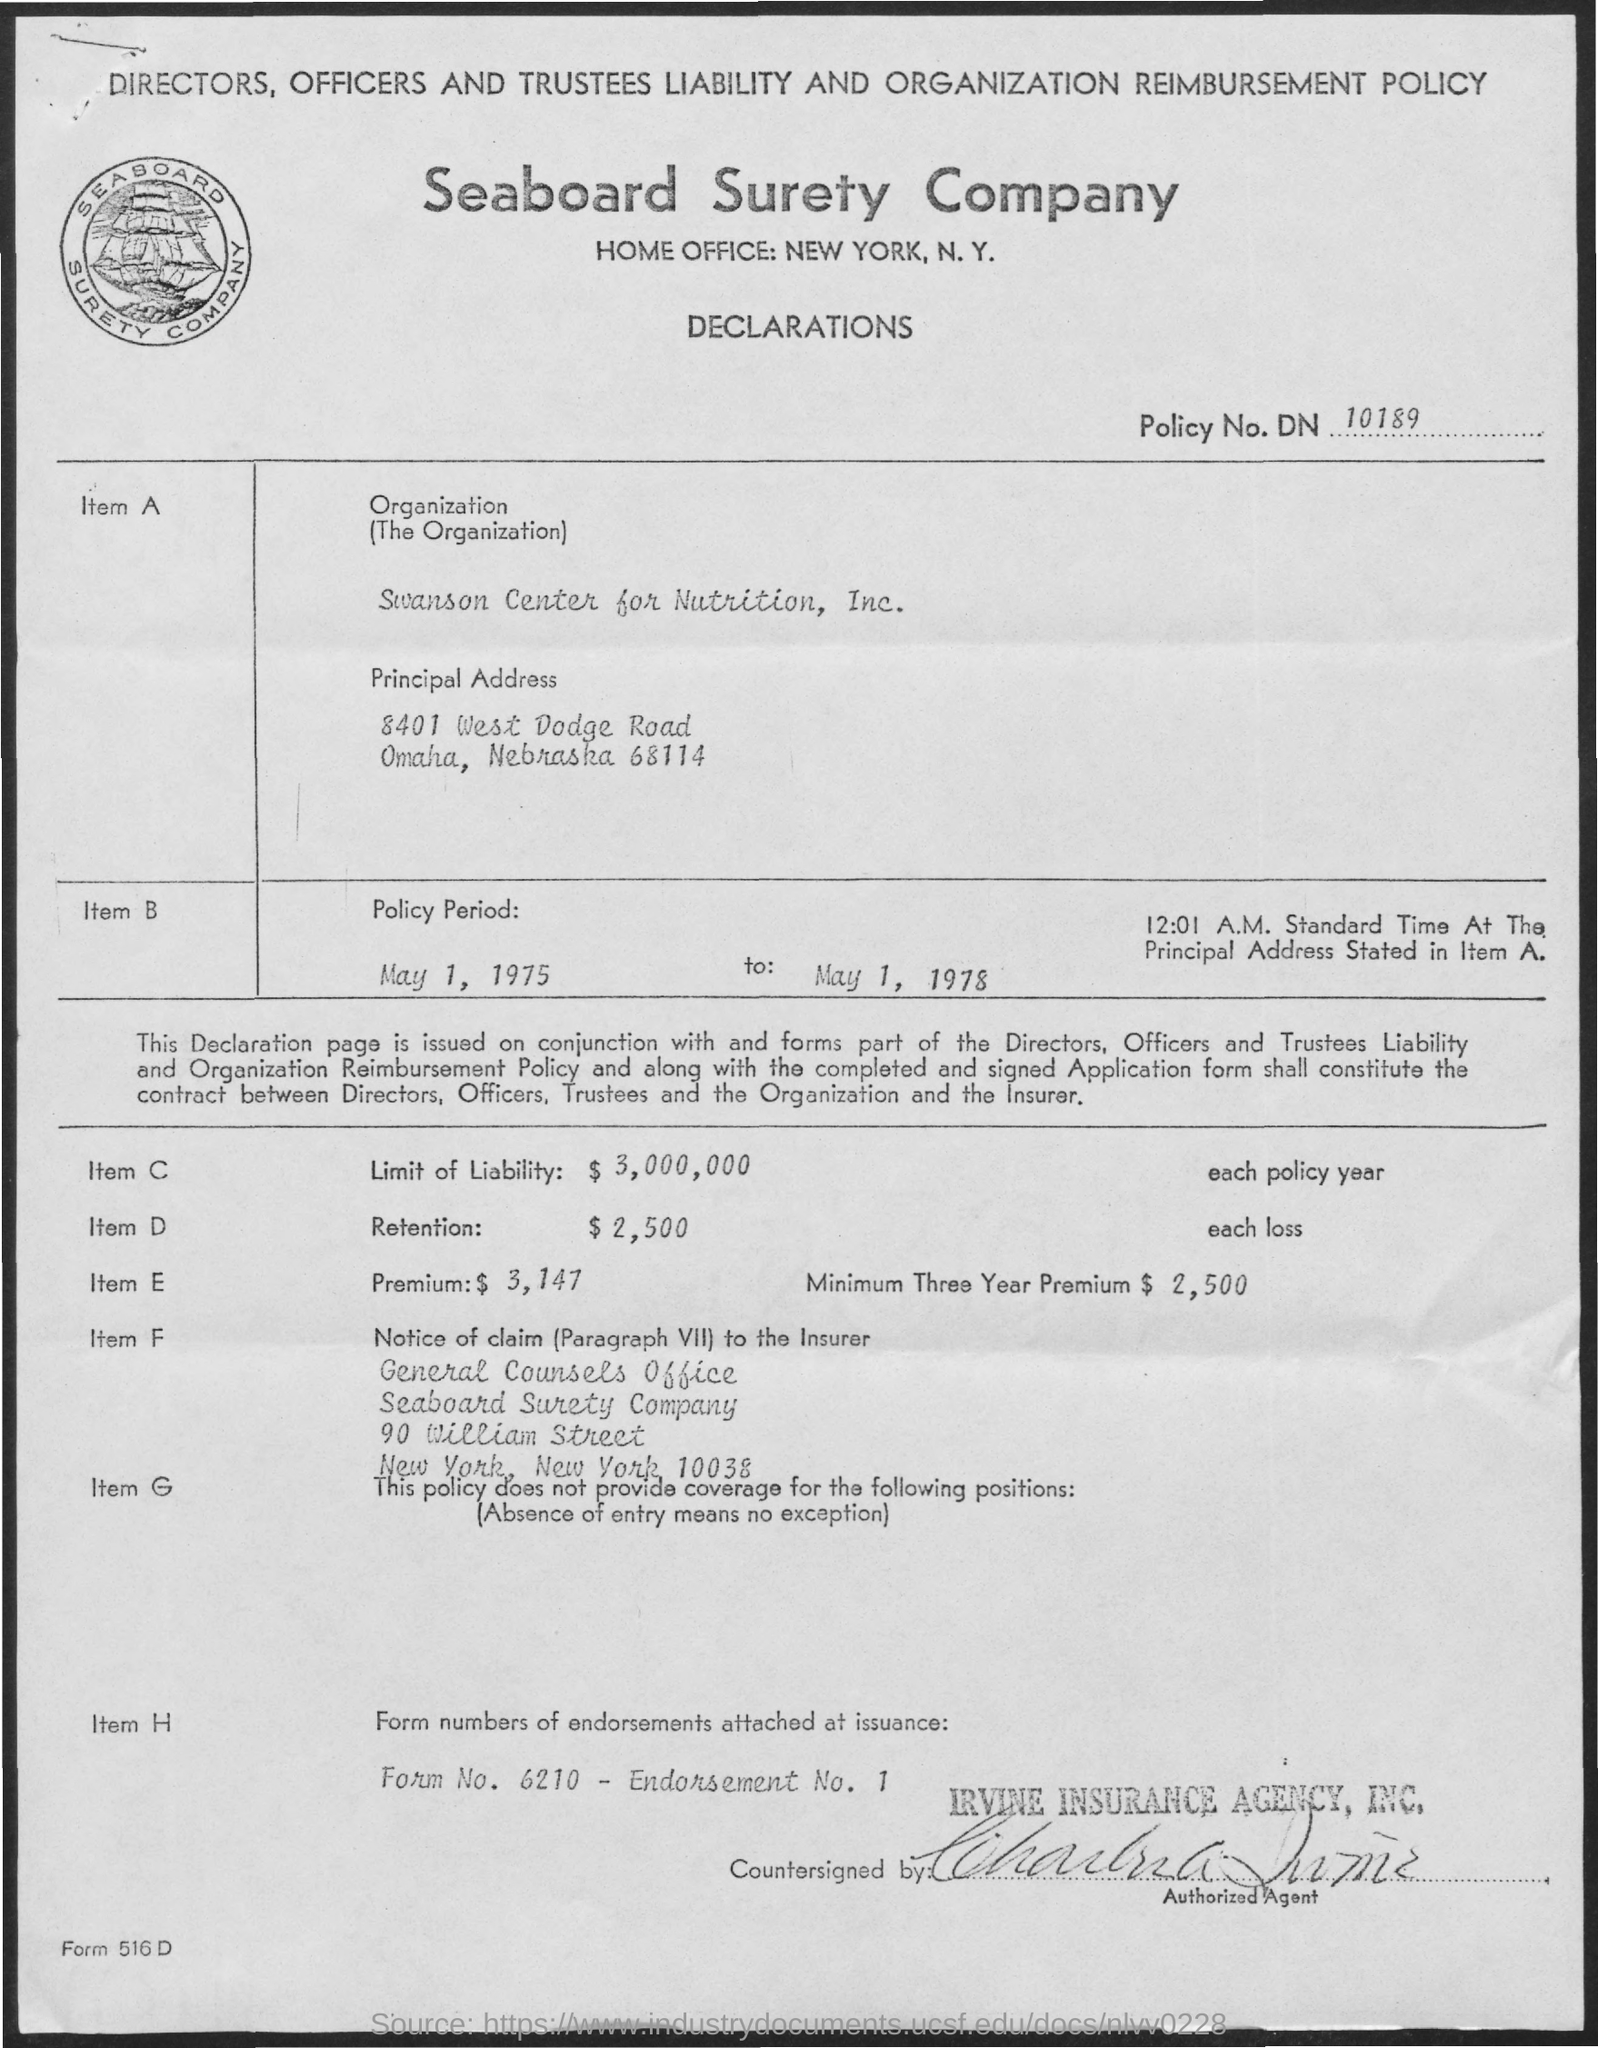what is the name of the company mentioned ? The document in the image refers to 'Seaboard Surety Company,' which is the name of the insurance company mentioned. The policy detailed in the image was issued for Directors, Officers, and Trustees Liability and Organization Reimbursement. 